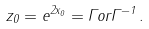<formula> <loc_0><loc_0><loc_500><loc_500>z _ { 0 } = e ^ { 2 x _ { 0 } } = \Gamma o r \Gamma ^ { - 1 } \, .</formula> 